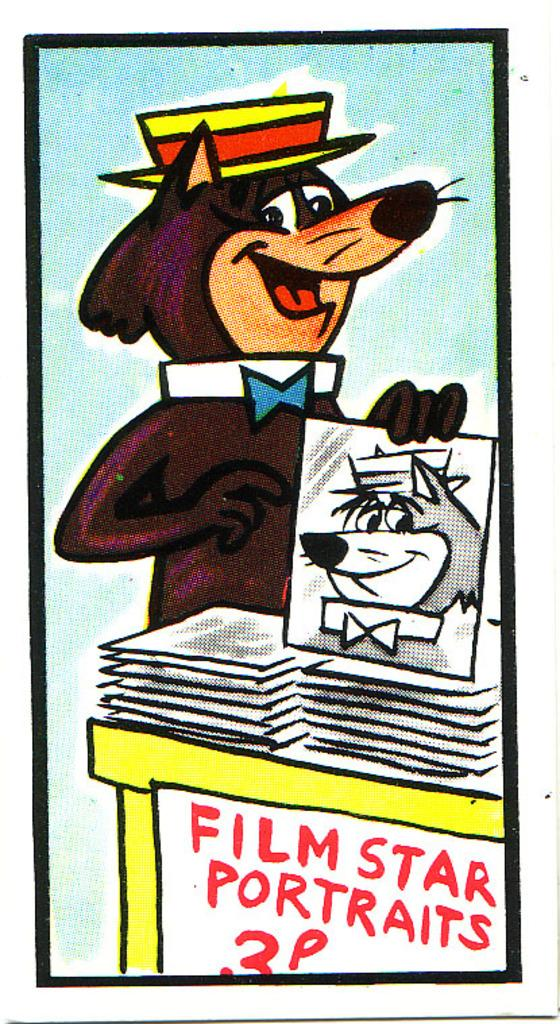<image>
Provide a brief description of the given image. A cartoon wolf wearing a hat and bowtie sells portraits of himself with a sign saying "Film Star Portraits" 